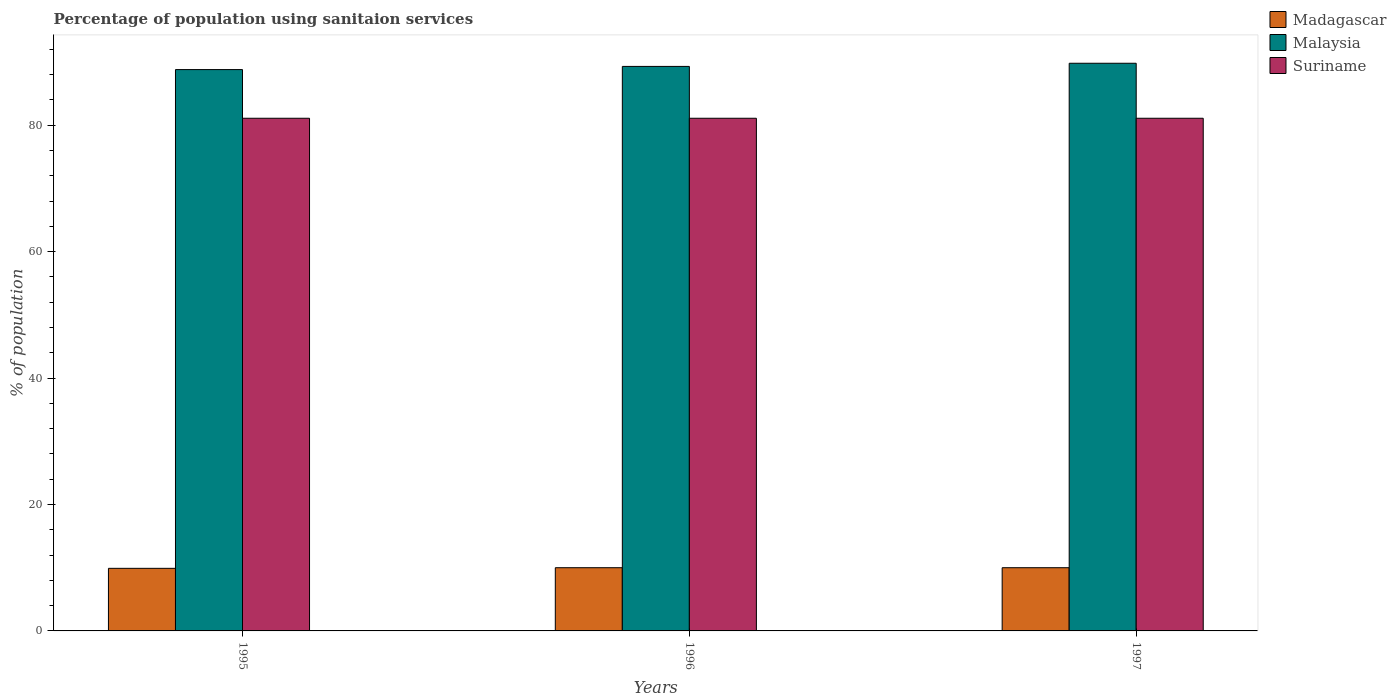How many different coloured bars are there?
Your answer should be very brief. 3. How many groups of bars are there?
Your response must be concise. 3. Are the number of bars on each tick of the X-axis equal?
Provide a succinct answer. Yes. In how many cases, is the number of bars for a given year not equal to the number of legend labels?
Your answer should be very brief. 0. Across all years, what is the maximum percentage of population using sanitaion services in Madagascar?
Your answer should be very brief. 10. Across all years, what is the minimum percentage of population using sanitaion services in Suriname?
Your answer should be very brief. 81.1. In which year was the percentage of population using sanitaion services in Malaysia maximum?
Ensure brevity in your answer.  1997. In which year was the percentage of population using sanitaion services in Suriname minimum?
Provide a short and direct response. 1995. What is the total percentage of population using sanitaion services in Malaysia in the graph?
Ensure brevity in your answer.  267.9. What is the difference between the percentage of population using sanitaion services in Malaysia in 1995 and that in 1996?
Provide a short and direct response. -0.5. What is the difference between the percentage of population using sanitaion services in Madagascar in 1997 and the percentage of population using sanitaion services in Malaysia in 1995?
Your response must be concise. -78.8. What is the average percentage of population using sanitaion services in Madagascar per year?
Provide a succinct answer. 9.97. In the year 1996, what is the difference between the percentage of population using sanitaion services in Malaysia and percentage of population using sanitaion services in Suriname?
Ensure brevity in your answer.  8.2. In how many years, is the percentage of population using sanitaion services in Suriname greater than 28 %?
Offer a very short reply. 3. What is the ratio of the percentage of population using sanitaion services in Malaysia in 1995 to that in 1996?
Your answer should be compact. 0.99. Is the difference between the percentage of population using sanitaion services in Malaysia in 1995 and 1997 greater than the difference between the percentage of population using sanitaion services in Suriname in 1995 and 1997?
Give a very brief answer. No. What is the difference between the highest and the lowest percentage of population using sanitaion services in Madagascar?
Offer a terse response. 0.1. What does the 2nd bar from the left in 1995 represents?
Your answer should be compact. Malaysia. What does the 1st bar from the right in 1995 represents?
Ensure brevity in your answer.  Suriname. Is it the case that in every year, the sum of the percentage of population using sanitaion services in Suriname and percentage of population using sanitaion services in Madagascar is greater than the percentage of population using sanitaion services in Malaysia?
Make the answer very short. Yes. How many bars are there?
Offer a very short reply. 9. Are all the bars in the graph horizontal?
Your response must be concise. No. Are the values on the major ticks of Y-axis written in scientific E-notation?
Your answer should be compact. No. Does the graph contain any zero values?
Ensure brevity in your answer.  No. Where does the legend appear in the graph?
Your answer should be compact. Top right. How many legend labels are there?
Provide a short and direct response. 3. What is the title of the graph?
Make the answer very short. Percentage of population using sanitaion services. What is the label or title of the Y-axis?
Provide a short and direct response. % of population. What is the % of population in Malaysia in 1995?
Provide a short and direct response. 88.8. What is the % of population in Suriname in 1995?
Keep it short and to the point. 81.1. What is the % of population of Malaysia in 1996?
Provide a succinct answer. 89.3. What is the % of population of Suriname in 1996?
Your answer should be compact. 81.1. What is the % of population of Malaysia in 1997?
Ensure brevity in your answer.  89.8. What is the % of population of Suriname in 1997?
Provide a short and direct response. 81.1. Across all years, what is the maximum % of population of Madagascar?
Offer a terse response. 10. Across all years, what is the maximum % of population in Malaysia?
Offer a very short reply. 89.8. Across all years, what is the maximum % of population of Suriname?
Ensure brevity in your answer.  81.1. Across all years, what is the minimum % of population in Madagascar?
Ensure brevity in your answer.  9.9. Across all years, what is the minimum % of population in Malaysia?
Provide a short and direct response. 88.8. Across all years, what is the minimum % of population in Suriname?
Ensure brevity in your answer.  81.1. What is the total % of population in Madagascar in the graph?
Keep it short and to the point. 29.9. What is the total % of population in Malaysia in the graph?
Make the answer very short. 267.9. What is the total % of population of Suriname in the graph?
Keep it short and to the point. 243.3. What is the difference between the % of population in Suriname in 1995 and that in 1996?
Give a very brief answer. 0. What is the difference between the % of population in Malaysia in 1995 and that in 1997?
Your answer should be very brief. -1. What is the difference between the % of population of Madagascar in 1995 and the % of population of Malaysia in 1996?
Keep it short and to the point. -79.4. What is the difference between the % of population in Madagascar in 1995 and the % of population in Suriname in 1996?
Provide a short and direct response. -71.2. What is the difference between the % of population in Malaysia in 1995 and the % of population in Suriname in 1996?
Offer a terse response. 7.7. What is the difference between the % of population in Madagascar in 1995 and the % of population in Malaysia in 1997?
Provide a succinct answer. -79.9. What is the difference between the % of population of Madagascar in 1995 and the % of population of Suriname in 1997?
Provide a short and direct response. -71.2. What is the difference between the % of population in Madagascar in 1996 and the % of population in Malaysia in 1997?
Ensure brevity in your answer.  -79.8. What is the difference between the % of population of Madagascar in 1996 and the % of population of Suriname in 1997?
Make the answer very short. -71.1. What is the average % of population in Madagascar per year?
Offer a very short reply. 9.97. What is the average % of population in Malaysia per year?
Offer a very short reply. 89.3. What is the average % of population of Suriname per year?
Your answer should be very brief. 81.1. In the year 1995, what is the difference between the % of population of Madagascar and % of population of Malaysia?
Provide a succinct answer. -78.9. In the year 1995, what is the difference between the % of population in Madagascar and % of population in Suriname?
Your response must be concise. -71.2. In the year 1996, what is the difference between the % of population in Madagascar and % of population in Malaysia?
Your answer should be very brief. -79.3. In the year 1996, what is the difference between the % of population in Madagascar and % of population in Suriname?
Offer a terse response. -71.1. In the year 1996, what is the difference between the % of population in Malaysia and % of population in Suriname?
Provide a succinct answer. 8.2. In the year 1997, what is the difference between the % of population of Madagascar and % of population of Malaysia?
Your response must be concise. -79.8. In the year 1997, what is the difference between the % of population of Madagascar and % of population of Suriname?
Keep it short and to the point. -71.1. What is the ratio of the % of population of Malaysia in 1995 to that in 1996?
Your response must be concise. 0.99. What is the ratio of the % of population of Suriname in 1995 to that in 1996?
Your answer should be compact. 1. What is the ratio of the % of population of Madagascar in 1995 to that in 1997?
Offer a very short reply. 0.99. What is the ratio of the % of population in Malaysia in 1995 to that in 1997?
Your response must be concise. 0.99. What is the ratio of the % of population in Suriname in 1995 to that in 1997?
Offer a terse response. 1. What is the ratio of the % of population in Malaysia in 1996 to that in 1997?
Offer a very short reply. 0.99. What is the difference between the highest and the second highest % of population in Madagascar?
Make the answer very short. 0. What is the difference between the highest and the lowest % of population in Malaysia?
Your answer should be very brief. 1. 